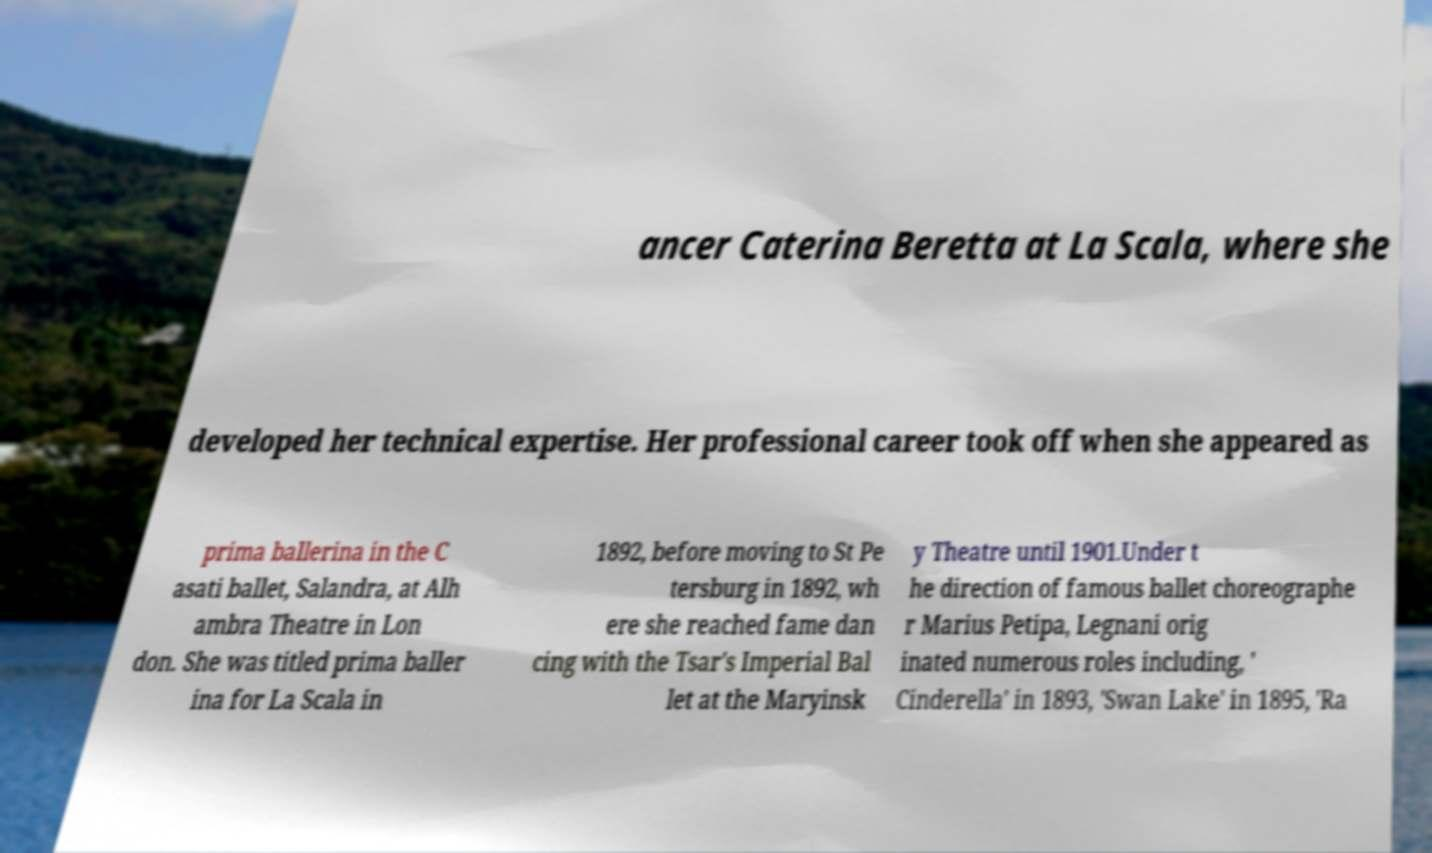For documentation purposes, I need the text within this image transcribed. Could you provide that? ancer Caterina Beretta at La Scala, where she developed her technical expertise. Her professional career took off when she appeared as prima ballerina in the C asati ballet, Salandra, at Alh ambra Theatre in Lon don. She was titled prima baller ina for La Scala in 1892, before moving to St Pe tersburg in 1892, wh ere she reached fame dan cing with the Tsar's Imperial Bal let at the Maryinsk y Theatre until 1901.Under t he direction of famous ballet choreographe r Marius Petipa, Legnani orig inated numerous roles including, ' Cinderella' in 1893, 'Swan Lake' in 1895, 'Ra 